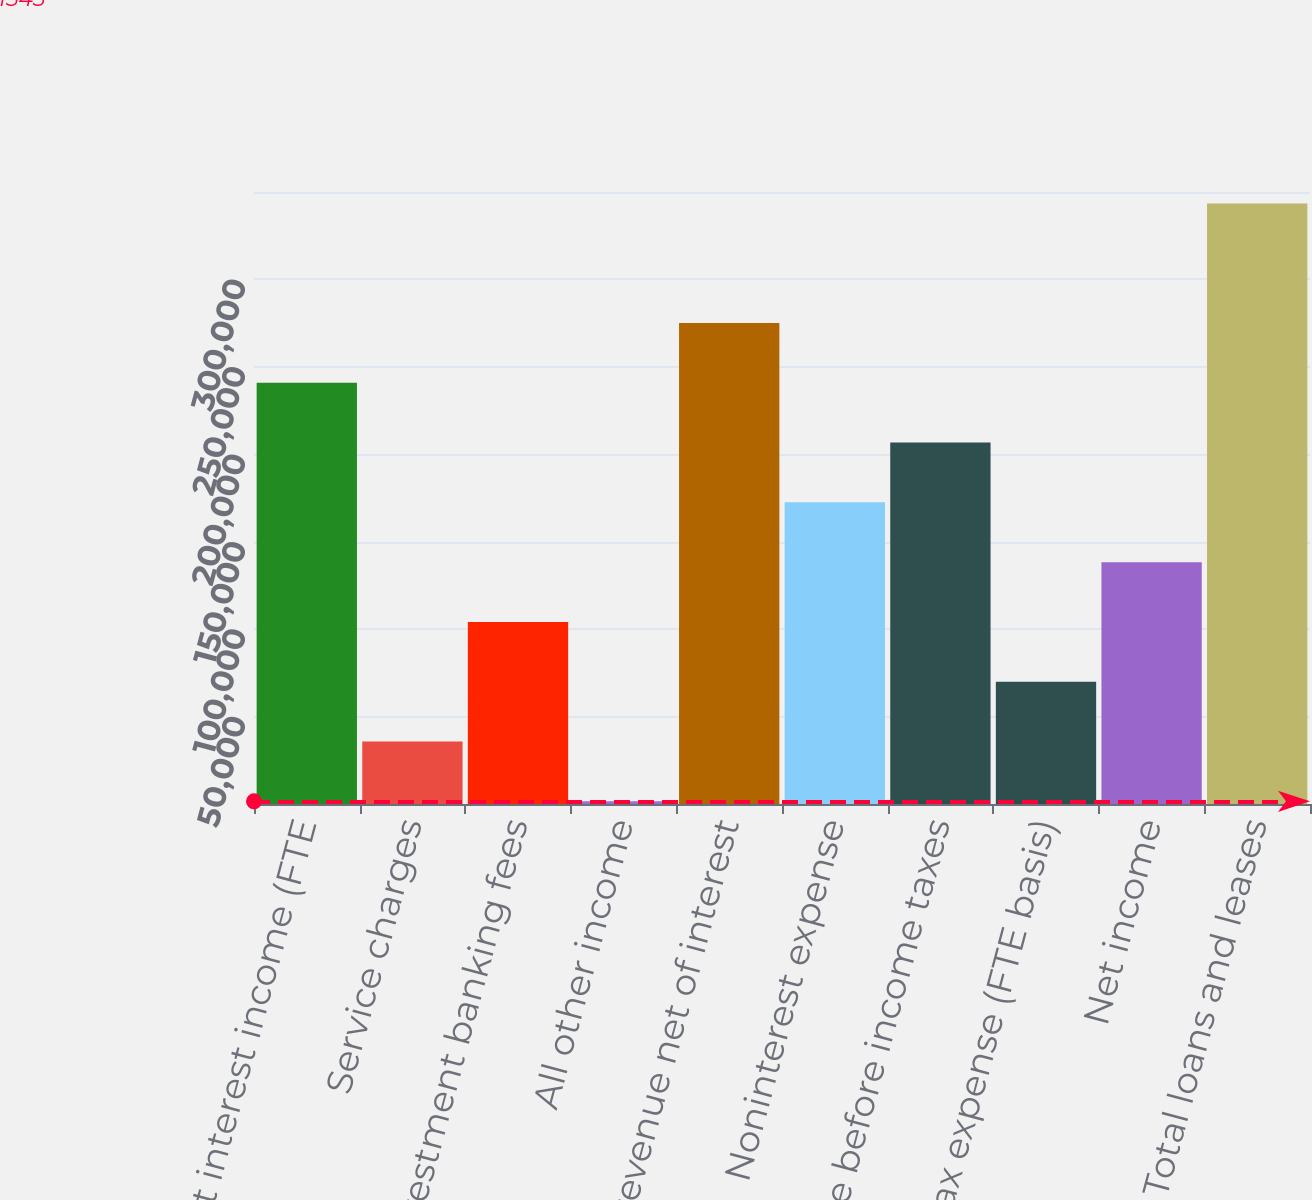Convert chart to OTSL. <chart><loc_0><loc_0><loc_500><loc_500><bar_chart><fcel>Net interest income (FTE<fcel>Service charges<fcel>Investment banking fees<fcel>All other income<fcel>Total revenue net of interest<fcel>Noninterest expense<fcel>Income before income taxes<fcel>Income tax expense (FTE basis)<fcel>Net income<fcel>Total loans and leases<nl><fcel>240888<fcel>35736.9<fcel>104121<fcel>1545<fcel>275080<fcel>172504<fcel>206696<fcel>69928.8<fcel>138313<fcel>343464<nl></chart> 